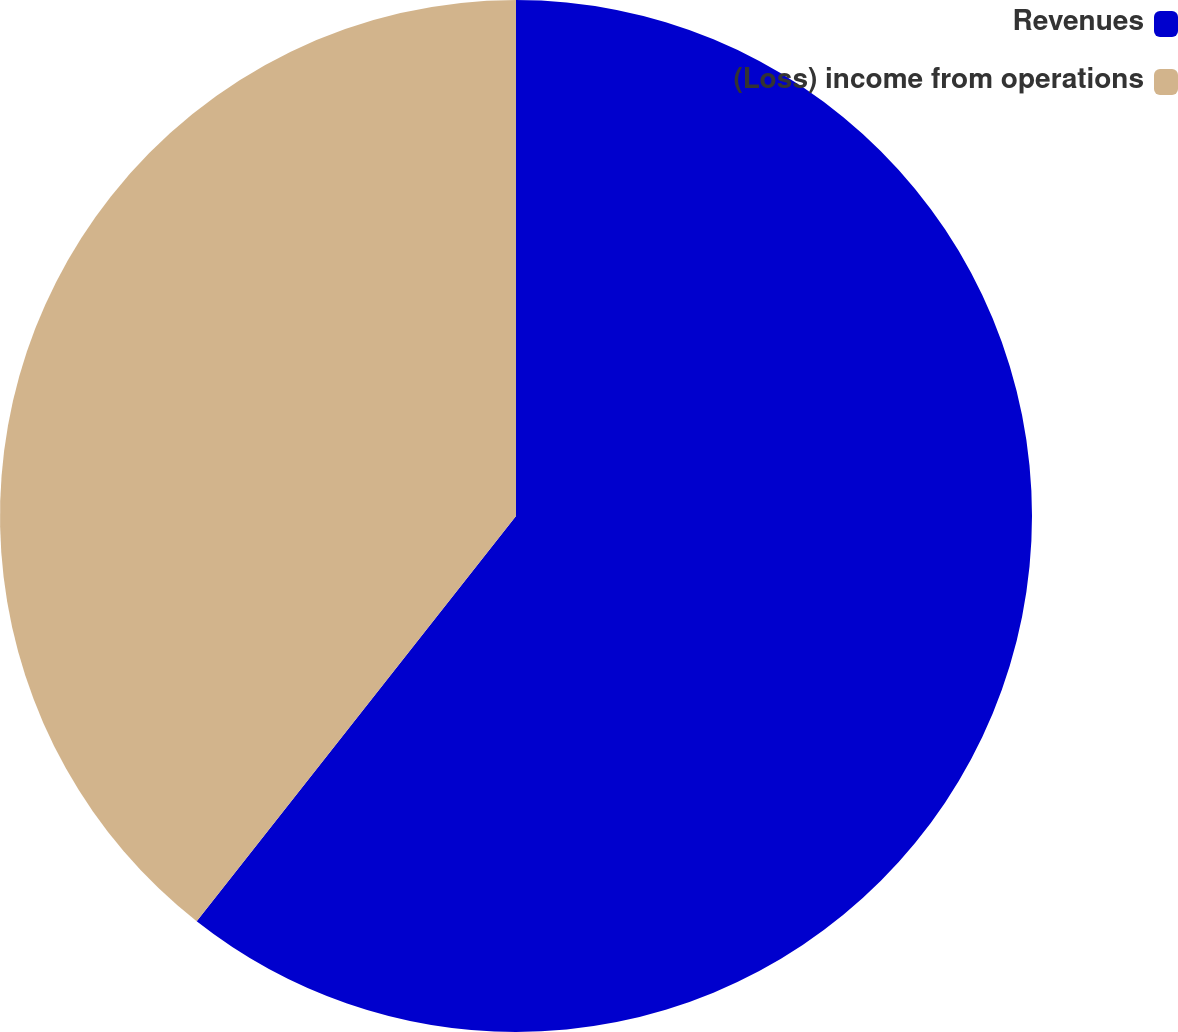Convert chart to OTSL. <chart><loc_0><loc_0><loc_500><loc_500><pie_chart><fcel>Revenues<fcel>(Loss) income from operations<nl><fcel>60.62%<fcel>39.38%<nl></chart> 